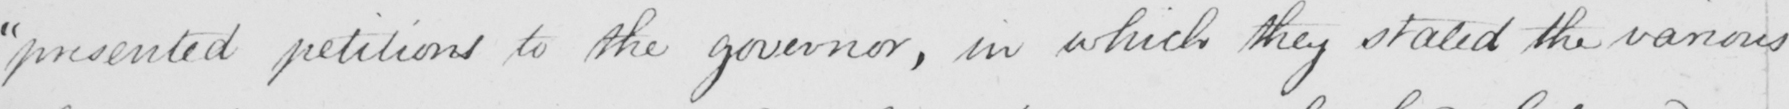Transcribe the text shown in this historical manuscript line. " presented petitions to the governor , in which they stated the various 